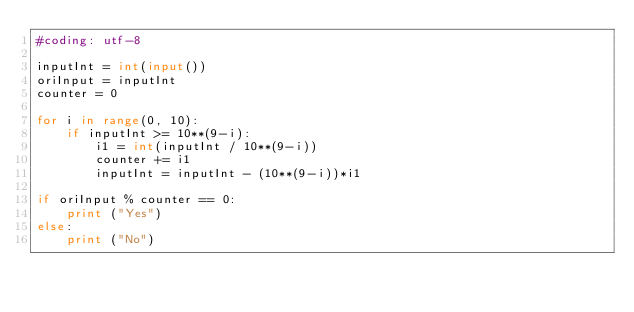Convert code to text. <code><loc_0><loc_0><loc_500><loc_500><_Python_>#coding: utf-8

inputInt = int(input())
oriInput = inputInt
counter = 0

for i in range(0, 10):
    if inputInt >= 10**(9-i):
        i1 = int(inputInt / 10**(9-i))
        counter += i1
        inputInt = inputInt - (10**(9-i))*i1

if oriInput % counter == 0:
    print ("Yes")
else:
    print ("No")</code> 